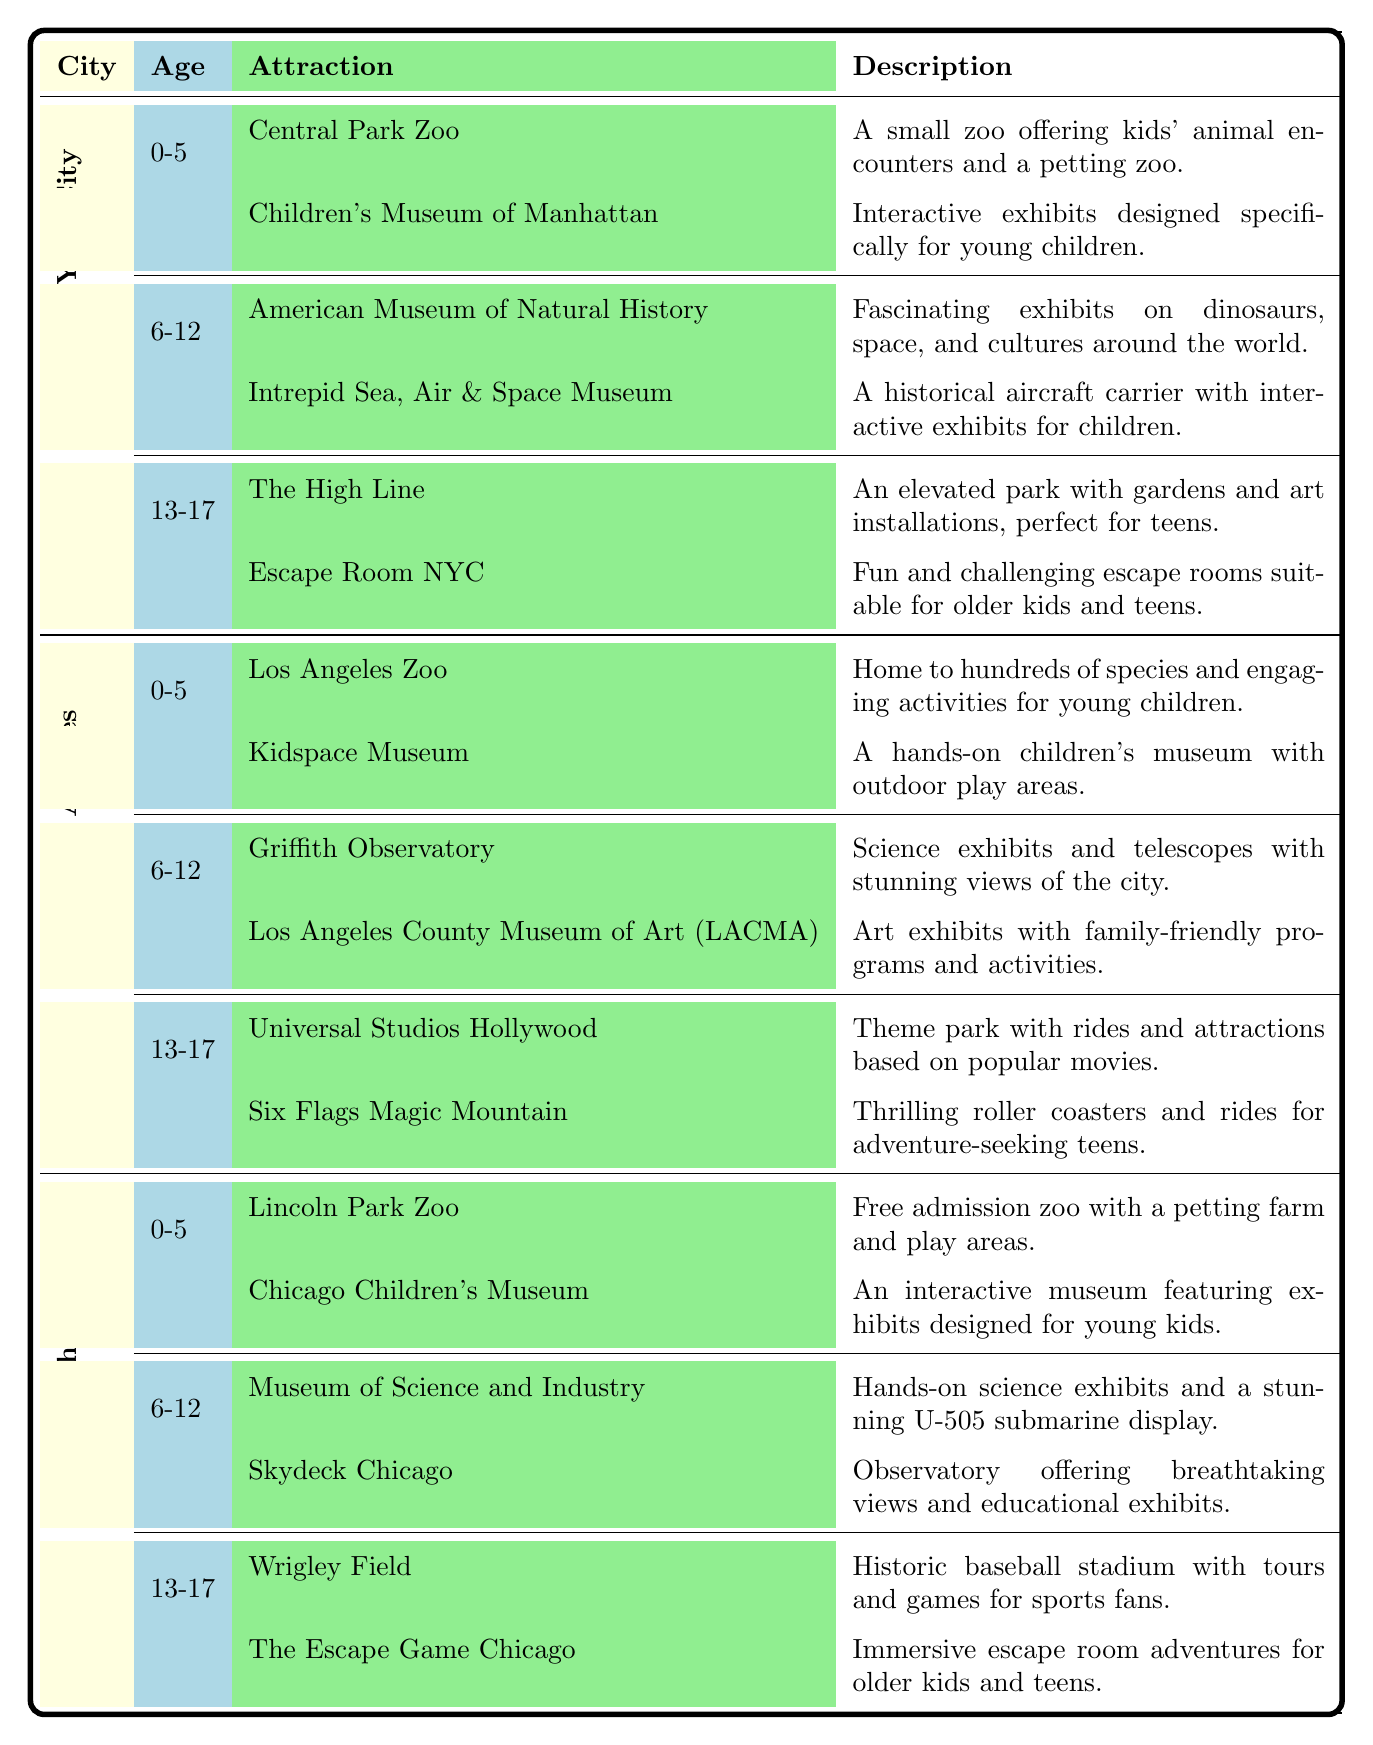What attractions are suitable for children aged 0-5 in Los Angeles? In the Los Angeles section, I check the 0-5 age group. The attractions listed are the Los Angeles Zoo and Kidspace Museum.
Answer: Los Angeles Zoo, Kidspace Museum How many attractions are listed for the age group 6-12 in New York City? In the New York City section, I examine the 6-12 age group. There are two attractions listed: American Museum of Natural History and Intrepid Sea, Air & Space Museum.
Answer: 2 Is Universal Studios Hollywood suitable for children under 13? Universal Studios Hollywood is listed under the age group 13-17, which means it is not specifically suitable for children under 13 years of age.
Answer: No What is the total number of attractions listed for Chicago across all age groups? I sum the attractions listed for all age groups in Chicago: 2 for 0-5, 2 for 6-12, and 2 for 13-17, giving a total of 2 + 2 + 2 = 6 attractions.
Answer: 6 Which city has more attractions for 13-17 year-olds, Chicago or Los Angeles? In Chicago, there are 2 attractions listed for 13-17 year-olds (Wrigley Field and The Escape Game Chicago), and in Los Angeles, there are also 2 attractions (Universal Studios Hollywood and Six Flags Magic Mountain). Since both cities have the same number of attractions for this age group, they are equal.
Answer: Equal What is the average number of attractions for the age group 6-12 across all cities? I count the number of attractions for 6-12 in each city: New York City has 2, Los Angeles has 2, and Chicago has 2. Adding these gives a total of 2 + 2 + 2 = 6 attractions. There are 3 cities, so the average is 6 / 3 = 2 attractions per city.
Answer: 2 Does the Children's Museum of Manhattan offer interactive exhibits for a younger audience? The Children's Museum of Manhattan is specifically mentioned to have interactive exhibits designed for young children (0-5 age group).
Answer: Yes What are the attractions suitable for ages 13-17 in New York City? In the New York City section for ages 13-17, the attractions are The High Line and Escape Room NYC.
Answer: The High Line, Escape Room NYC 